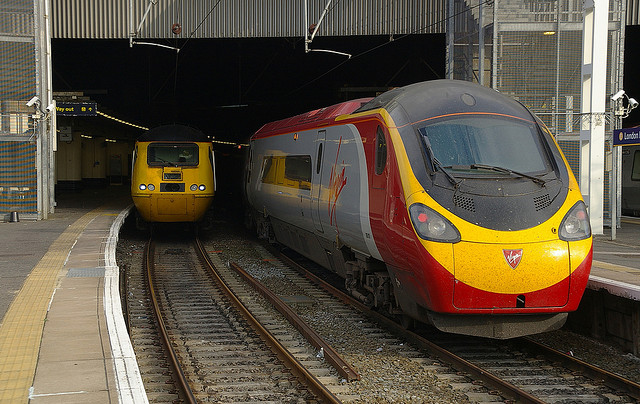What type of trains are shown in the image? The image shows two types of passenger trains commonly used for medium to long distance travel. They appear to be models from the UK rail network. Can you tell me about the station they are at? While I can't specify the exact station, it's clearly a larger station with multiple platforms, overhead coverings, and modern amenities, indicative of a station that handles a high volume of traffic and provides intercity connections. 